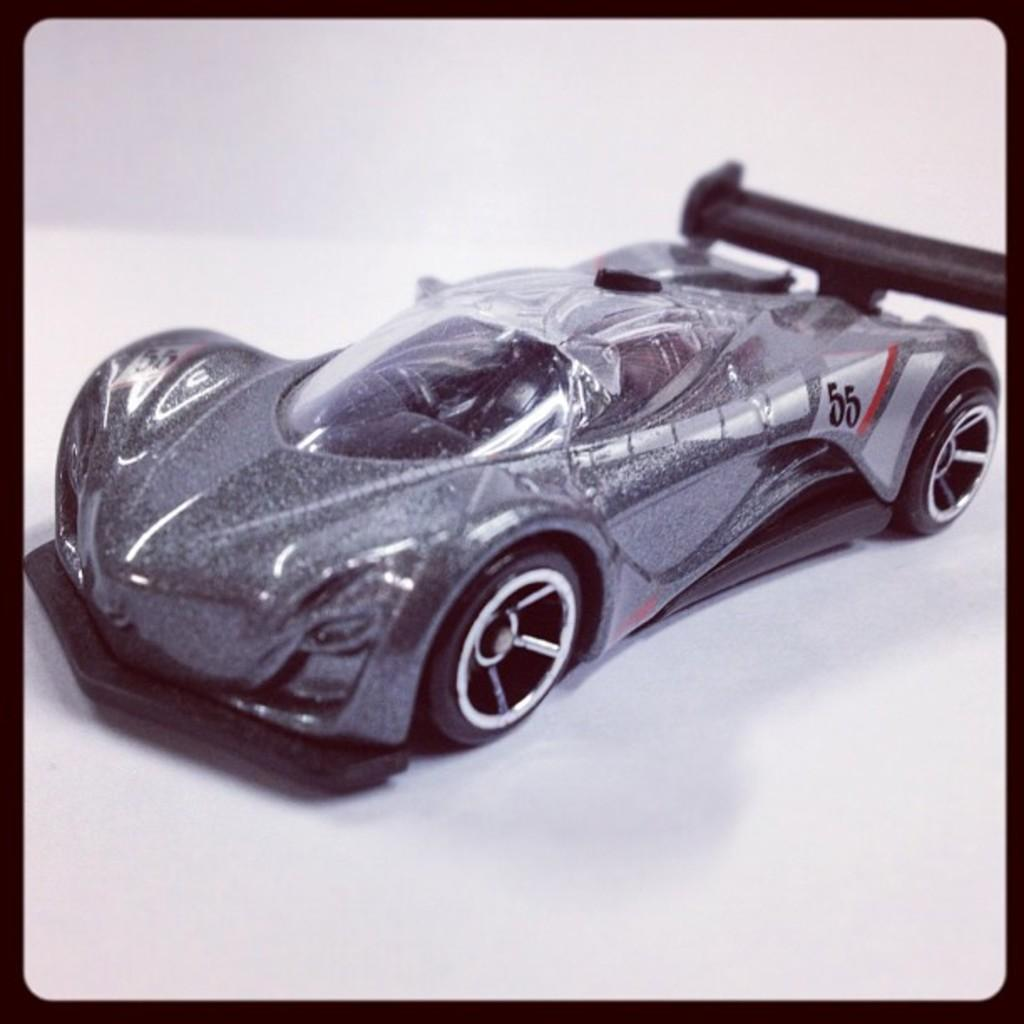<image>
Render a clear and concise summary of the photo. a childs car with a number 55 is black and white 